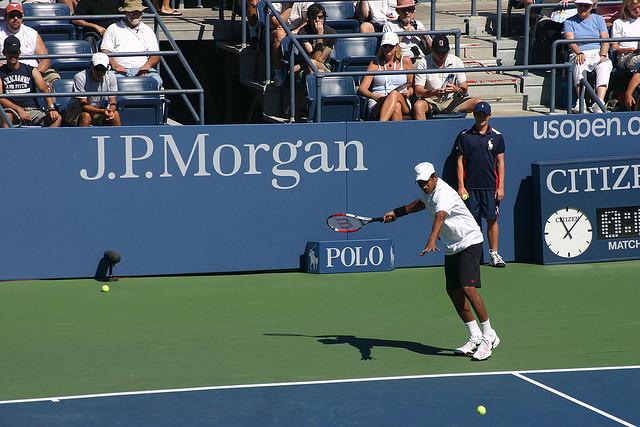Is the player on the baseline or service line?
Keep it brief. Base. What sport is this?
Short answer required. Tennis. Which direction is the ball going?
Keep it brief. Towards player. 